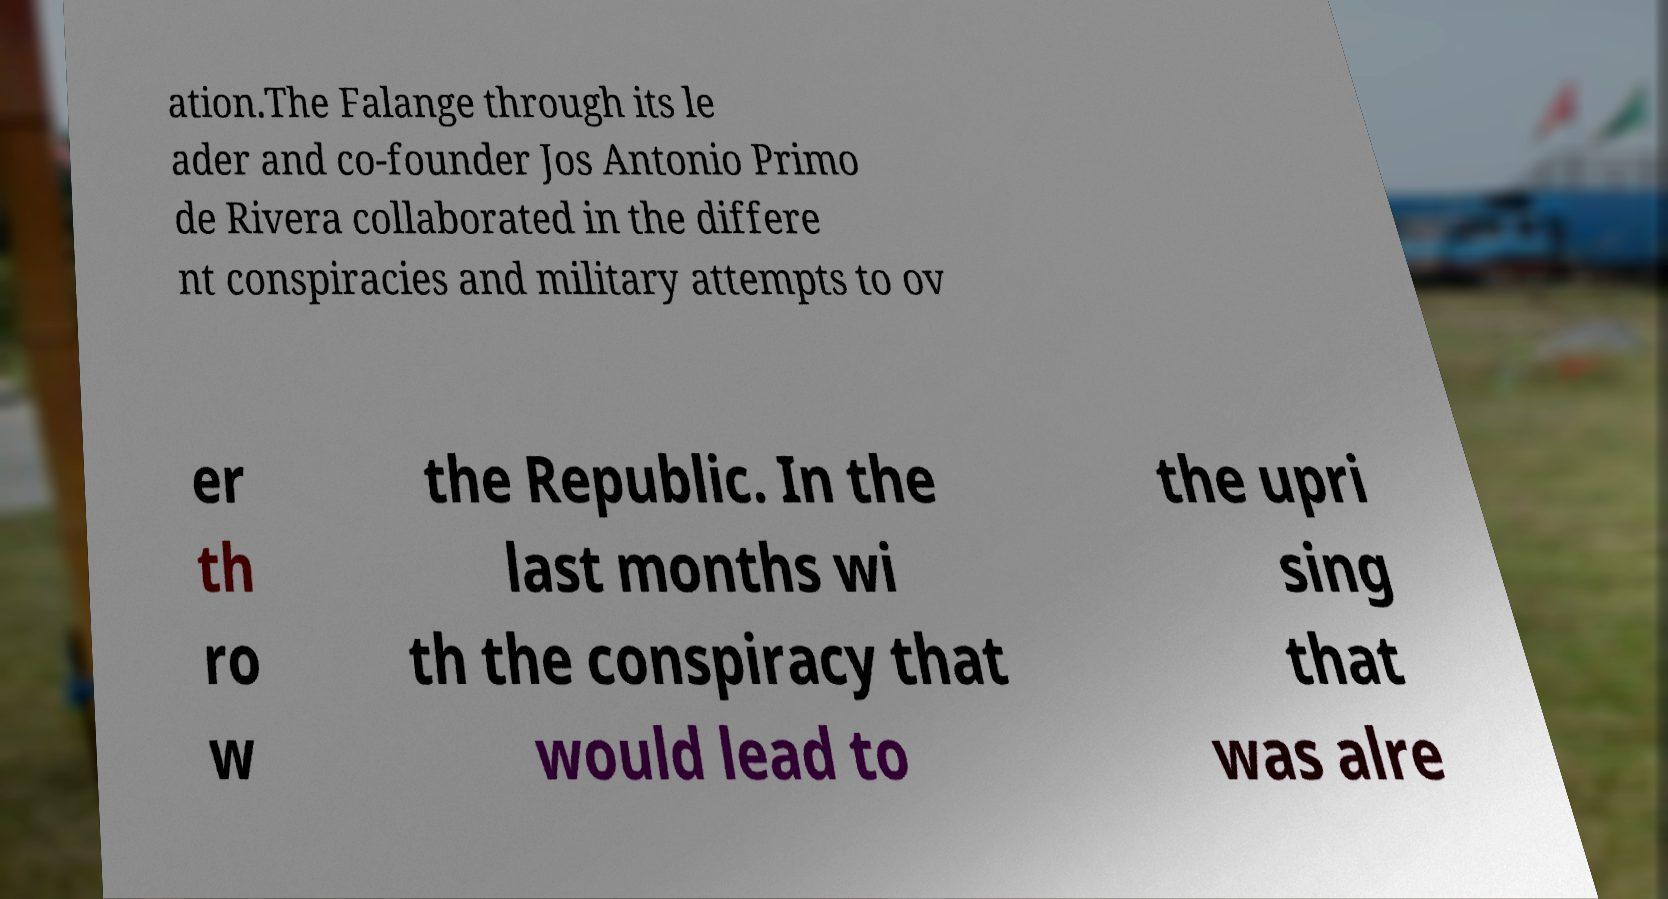Can you read and provide the text displayed in the image?This photo seems to have some interesting text. Can you extract and type it out for me? ation.The Falange through its le ader and co-founder Jos Antonio Primo de Rivera collaborated in the differe nt conspiracies and military attempts to ov er th ro w the Republic. In the last months wi th the conspiracy that would lead to the upri sing that was alre 